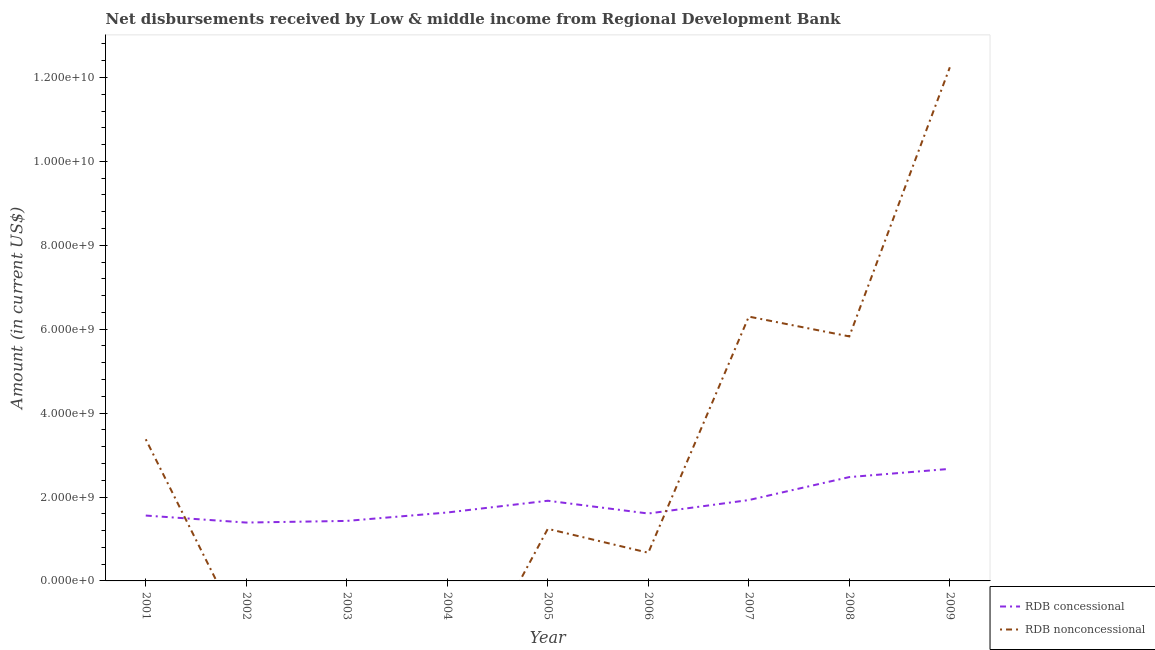How many different coloured lines are there?
Offer a very short reply. 2. Does the line corresponding to net non concessional disbursements from rdb intersect with the line corresponding to net concessional disbursements from rdb?
Make the answer very short. Yes. What is the net non concessional disbursements from rdb in 2001?
Offer a terse response. 3.38e+09. Across all years, what is the maximum net concessional disbursements from rdb?
Make the answer very short. 2.67e+09. Across all years, what is the minimum net concessional disbursements from rdb?
Offer a terse response. 1.39e+09. In which year was the net non concessional disbursements from rdb maximum?
Provide a succinct answer. 2009. What is the total net concessional disbursements from rdb in the graph?
Your answer should be very brief. 1.66e+1. What is the difference between the net concessional disbursements from rdb in 2005 and that in 2008?
Provide a succinct answer. -5.64e+08. What is the difference between the net concessional disbursements from rdb in 2005 and the net non concessional disbursements from rdb in 2003?
Give a very brief answer. 1.91e+09. What is the average net concessional disbursements from rdb per year?
Keep it short and to the point. 1.84e+09. In the year 2008, what is the difference between the net concessional disbursements from rdb and net non concessional disbursements from rdb?
Your answer should be compact. -3.35e+09. What is the ratio of the net concessional disbursements from rdb in 2003 to that in 2009?
Offer a terse response. 0.54. Is the net non concessional disbursements from rdb in 2007 less than that in 2009?
Keep it short and to the point. Yes. Is the difference between the net concessional disbursements from rdb in 2001 and 2007 greater than the difference between the net non concessional disbursements from rdb in 2001 and 2007?
Provide a succinct answer. Yes. What is the difference between the highest and the second highest net concessional disbursements from rdb?
Give a very brief answer. 1.96e+08. What is the difference between the highest and the lowest net concessional disbursements from rdb?
Make the answer very short. 1.28e+09. Is the sum of the net concessional disbursements from rdb in 2005 and 2008 greater than the maximum net non concessional disbursements from rdb across all years?
Provide a succinct answer. No. Does the net concessional disbursements from rdb monotonically increase over the years?
Your answer should be very brief. No. How many years are there in the graph?
Offer a terse response. 9. Are the values on the major ticks of Y-axis written in scientific E-notation?
Your response must be concise. Yes. Does the graph contain any zero values?
Keep it short and to the point. Yes. Does the graph contain grids?
Keep it short and to the point. No. How many legend labels are there?
Provide a short and direct response. 2. What is the title of the graph?
Your response must be concise. Net disbursements received by Low & middle income from Regional Development Bank. What is the label or title of the X-axis?
Your response must be concise. Year. What is the label or title of the Y-axis?
Keep it short and to the point. Amount (in current US$). What is the Amount (in current US$) in RDB concessional in 2001?
Ensure brevity in your answer.  1.56e+09. What is the Amount (in current US$) in RDB nonconcessional in 2001?
Your response must be concise. 3.38e+09. What is the Amount (in current US$) of RDB concessional in 2002?
Provide a short and direct response. 1.39e+09. What is the Amount (in current US$) of RDB nonconcessional in 2002?
Your answer should be compact. 0. What is the Amount (in current US$) in RDB concessional in 2003?
Give a very brief answer. 1.43e+09. What is the Amount (in current US$) of RDB nonconcessional in 2003?
Offer a very short reply. 0. What is the Amount (in current US$) of RDB concessional in 2004?
Your answer should be very brief. 1.63e+09. What is the Amount (in current US$) in RDB concessional in 2005?
Your response must be concise. 1.91e+09. What is the Amount (in current US$) of RDB nonconcessional in 2005?
Offer a terse response. 1.24e+09. What is the Amount (in current US$) of RDB concessional in 2006?
Make the answer very short. 1.61e+09. What is the Amount (in current US$) of RDB nonconcessional in 2006?
Your answer should be compact. 6.72e+08. What is the Amount (in current US$) of RDB concessional in 2007?
Provide a short and direct response. 1.93e+09. What is the Amount (in current US$) of RDB nonconcessional in 2007?
Keep it short and to the point. 6.30e+09. What is the Amount (in current US$) of RDB concessional in 2008?
Your response must be concise. 2.48e+09. What is the Amount (in current US$) in RDB nonconcessional in 2008?
Provide a short and direct response. 5.83e+09. What is the Amount (in current US$) of RDB concessional in 2009?
Offer a very short reply. 2.67e+09. What is the Amount (in current US$) in RDB nonconcessional in 2009?
Make the answer very short. 1.22e+1. Across all years, what is the maximum Amount (in current US$) in RDB concessional?
Give a very brief answer. 2.67e+09. Across all years, what is the maximum Amount (in current US$) in RDB nonconcessional?
Your answer should be very brief. 1.22e+1. Across all years, what is the minimum Amount (in current US$) in RDB concessional?
Provide a short and direct response. 1.39e+09. What is the total Amount (in current US$) in RDB concessional in the graph?
Ensure brevity in your answer.  1.66e+1. What is the total Amount (in current US$) of RDB nonconcessional in the graph?
Your answer should be very brief. 2.97e+1. What is the difference between the Amount (in current US$) in RDB concessional in 2001 and that in 2002?
Offer a terse response. 1.67e+08. What is the difference between the Amount (in current US$) in RDB concessional in 2001 and that in 2003?
Your answer should be very brief. 1.28e+08. What is the difference between the Amount (in current US$) of RDB concessional in 2001 and that in 2004?
Give a very brief answer. -7.27e+07. What is the difference between the Amount (in current US$) of RDB concessional in 2001 and that in 2005?
Make the answer very short. -3.53e+08. What is the difference between the Amount (in current US$) in RDB nonconcessional in 2001 and that in 2005?
Provide a succinct answer. 2.13e+09. What is the difference between the Amount (in current US$) in RDB concessional in 2001 and that in 2006?
Give a very brief answer. -4.85e+07. What is the difference between the Amount (in current US$) in RDB nonconcessional in 2001 and that in 2006?
Provide a short and direct response. 2.70e+09. What is the difference between the Amount (in current US$) in RDB concessional in 2001 and that in 2007?
Give a very brief answer. -3.69e+08. What is the difference between the Amount (in current US$) in RDB nonconcessional in 2001 and that in 2007?
Your answer should be very brief. -2.92e+09. What is the difference between the Amount (in current US$) in RDB concessional in 2001 and that in 2008?
Offer a terse response. -9.17e+08. What is the difference between the Amount (in current US$) in RDB nonconcessional in 2001 and that in 2008?
Make the answer very short. -2.45e+09. What is the difference between the Amount (in current US$) in RDB concessional in 2001 and that in 2009?
Provide a succinct answer. -1.11e+09. What is the difference between the Amount (in current US$) of RDB nonconcessional in 2001 and that in 2009?
Ensure brevity in your answer.  -8.87e+09. What is the difference between the Amount (in current US$) in RDB concessional in 2002 and that in 2003?
Keep it short and to the point. -3.94e+07. What is the difference between the Amount (in current US$) in RDB concessional in 2002 and that in 2004?
Your answer should be very brief. -2.40e+08. What is the difference between the Amount (in current US$) of RDB concessional in 2002 and that in 2005?
Provide a succinct answer. -5.20e+08. What is the difference between the Amount (in current US$) in RDB concessional in 2002 and that in 2006?
Offer a very short reply. -2.16e+08. What is the difference between the Amount (in current US$) of RDB concessional in 2002 and that in 2007?
Offer a terse response. -5.36e+08. What is the difference between the Amount (in current US$) in RDB concessional in 2002 and that in 2008?
Your response must be concise. -1.08e+09. What is the difference between the Amount (in current US$) of RDB concessional in 2002 and that in 2009?
Keep it short and to the point. -1.28e+09. What is the difference between the Amount (in current US$) in RDB concessional in 2003 and that in 2004?
Keep it short and to the point. -2.00e+08. What is the difference between the Amount (in current US$) of RDB concessional in 2003 and that in 2005?
Provide a short and direct response. -4.81e+08. What is the difference between the Amount (in current US$) in RDB concessional in 2003 and that in 2006?
Your answer should be compact. -1.76e+08. What is the difference between the Amount (in current US$) of RDB concessional in 2003 and that in 2007?
Your answer should be very brief. -4.97e+08. What is the difference between the Amount (in current US$) of RDB concessional in 2003 and that in 2008?
Provide a short and direct response. -1.04e+09. What is the difference between the Amount (in current US$) of RDB concessional in 2003 and that in 2009?
Your response must be concise. -1.24e+09. What is the difference between the Amount (in current US$) of RDB concessional in 2004 and that in 2005?
Offer a terse response. -2.80e+08. What is the difference between the Amount (in current US$) in RDB concessional in 2004 and that in 2006?
Provide a short and direct response. 2.43e+07. What is the difference between the Amount (in current US$) of RDB concessional in 2004 and that in 2007?
Give a very brief answer. -2.97e+08. What is the difference between the Amount (in current US$) in RDB concessional in 2004 and that in 2008?
Ensure brevity in your answer.  -8.44e+08. What is the difference between the Amount (in current US$) in RDB concessional in 2004 and that in 2009?
Make the answer very short. -1.04e+09. What is the difference between the Amount (in current US$) in RDB concessional in 2005 and that in 2006?
Your answer should be very brief. 3.04e+08. What is the difference between the Amount (in current US$) of RDB nonconcessional in 2005 and that in 2006?
Provide a short and direct response. 5.70e+08. What is the difference between the Amount (in current US$) in RDB concessional in 2005 and that in 2007?
Make the answer very short. -1.63e+07. What is the difference between the Amount (in current US$) in RDB nonconcessional in 2005 and that in 2007?
Offer a terse response. -5.06e+09. What is the difference between the Amount (in current US$) of RDB concessional in 2005 and that in 2008?
Your answer should be compact. -5.64e+08. What is the difference between the Amount (in current US$) in RDB nonconcessional in 2005 and that in 2008?
Provide a succinct answer. -4.59e+09. What is the difference between the Amount (in current US$) of RDB concessional in 2005 and that in 2009?
Offer a very short reply. -7.60e+08. What is the difference between the Amount (in current US$) in RDB nonconcessional in 2005 and that in 2009?
Your answer should be compact. -1.10e+1. What is the difference between the Amount (in current US$) in RDB concessional in 2006 and that in 2007?
Provide a short and direct response. -3.21e+08. What is the difference between the Amount (in current US$) of RDB nonconcessional in 2006 and that in 2007?
Provide a succinct answer. -5.63e+09. What is the difference between the Amount (in current US$) in RDB concessional in 2006 and that in 2008?
Offer a very short reply. -8.69e+08. What is the difference between the Amount (in current US$) of RDB nonconcessional in 2006 and that in 2008?
Your answer should be compact. -5.16e+09. What is the difference between the Amount (in current US$) of RDB concessional in 2006 and that in 2009?
Give a very brief answer. -1.06e+09. What is the difference between the Amount (in current US$) in RDB nonconcessional in 2006 and that in 2009?
Your answer should be compact. -1.16e+1. What is the difference between the Amount (in current US$) of RDB concessional in 2007 and that in 2008?
Provide a succinct answer. -5.48e+08. What is the difference between the Amount (in current US$) of RDB nonconcessional in 2007 and that in 2008?
Ensure brevity in your answer.  4.72e+08. What is the difference between the Amount (in current US$) in RDB concessional in 2007 and that in 2009?
Offer a terse response. -7.43e+08. What is the difference between the Amount (in current US$) of RDB nonconcessional in 2007 and that in 2009?
Offer a terse response. -5.94e+09. What is the difference between the Amount (in current US$) of RDB concessional in 2008 and that in 2009?
Offer a terse response. -1.96e+08. What is the difference between the Amount (in current US$) of RDB nonconcessional in 2008 and that in 2009?
Your answer should be very brief. -6.41e+09. What is the difference between the Amount (in current US$) of RDB concessional in 2001 and the Amount (in current US$) of RDB nonconcessional in 2005?
Ensure brevity in your answer.  3.17e+08. What is the difference between the Amount (in current US$) in RDB concessional in 2001 and the Amount (in current US$) in RDB nonconcessional in 2006?
Your response must be concise. 8.86e+08. What is the difference between the Amount (in current US$) of RDB concessional in 2001 and the Amount (in current US$) of RDB nonconcessional in 2007?
Your answer should be very brief. -4.74e+09. What is the difference between the Amount (in current US$) in RDB concessional in 2001 and the Amount (in current US$) in RDB nonconcessional in 2008?
Your response must be concise. -4.27e+09. What is the difference between the Amount (in current US$) of RDB concessional in 2001 and the Amount (in current US$) of RDB nonconcessional in 2009?
Provide a short and direct response. -1.07e+1. What is the difference between the Amount (in current US$) of RDB concessional in 2002 and the Amount (in current US$) of RDB nonconcessional in 2005?
Make the answer very short. 1.50e+08. What is the difference between the Amount (in current US$) of RDB concessional in 2002 and the Amount (in current US$) of RDB nonconcessional in 2006?
Your answer should be compact. 7.19e+08. What is the difference between the Amount (in current US$) in RDB concessional in 2002 and the Amount (in current US$) in RDB nonconcessional in 2007?
Offer a very short reply. -4.91e+09. What is the difference between the Amount (in current US$) in RDB concessional in 2002 and the Amount (in current US$) in RDB nonconcessional in 2008?
Your response must be concise. -4.44e+09. What is the difference between the Amount (in current US$) in RDB concessional in 2002 and the Amount (in current US$) in RDB nonconcessional in 2009?
Your answer should be very brief. -1.09e+1. What is the difference between the Amount (in current US$) of RDB concessional in 2003 and the Amount (in current US$) of RDB nonconcessional in 2005?
Provide a short and direct response. 1.89e+08. What is the difference between the Amount (in current US$) in RDB concessional in 2003 and the Amount (in current US$) in RDB nonconcessional in 2006?
Give a very brief answer. 7.59e+08. What is the difference between the Amount (in current US$) in RDB concessional in 2003 and the Amount (in current US$) in RDB nonconcessional in 2007?
Your answer should be compact. -4.87e+09. What is the difference between the Amount (in current US$) in RDB concessional in 2003 and the Amount (in current US$) in RDB nonconcessional in 2008?
Provide a succinct answer. -4.40e+09. What is the difference between the Amount (in current US$) in RDB concessional in 2003 and the Amount (in current US$) in RDB nonconcessional in 2009?
Your answer should be very brief. -1.08e+1. What is the difference between the Amount (in current US$) of RDB concessional in 2004 and the Amount (in current US$) of RDB nonconcessional in 2005?
Give a very brief answer. 3.89e+08. What is the difference between the Amount (in current US$) of RDB concessional in 2004 and the Amount (in current US$) of RDB nonconcessional in 2006?
Offer a terse response. 9.59e+08. What is the difference between the Amount (in current US$) in RDB concessional in 2004 and the Amount (in current US$) in RDB nonconcessional in 2007?
Offer a very short reply. -4.67e+09. What is the difference between the Amount (in current US$) in RDB concessional in 2004 and the Amount (in current US$) in RDB nonconcessional in 2008?
Make the answer very short. -4.20e+09. What is the difference between the Amount (in current US$) in RDB concessional in 2004 and the Amount (in current US$) in RDB nonconcessional in 2009?
Keep it short and to the point. -1.06e+1. What is the difference between the Amount (in current US$) in RDB concessional in 2005 and the Amount (in current US$) in RDB nonconcessional in 2006?
Your answer should be compact. 1.24e+09. What is the difference between the Amount (in current US$) in RDB concessional in 2005 and the Amount (in current US$) in RDB nonconcessional in 2007?
Provide a succinct answer. -4.39e+09. What is the difference between the Amount (in current US$) of RDB concessional in 2005 and the Amount (in current US$) of RDB nonconcessional in 2008?
Provide a short and direct response. -3.92e+09. What is the difference between the Amount (in current US$) in RDB concessional in 2005 and the Amount (in current US$) in RDB nonconcessional in 2009?
Give a very brief answer. -1.03e+1. What is the difference between the Amount (in current US$) of RDB concessional in 2006 and the Amount (in current US$) of RDB nonconcessional in 2007?
Provide a succinct answer. -4.69e+09. What is the difference between the Amount (in current US$) of RDB concessional in 2006 and the Amount (in current US$) of RDB nonconcessional in 2008?
Offer a very short reply. -4.22e+09. What is the difference between the Amount (in current US$) in RDB concessional in 2006 and the Amount (in current US$) in RDB nonconcessional in 2009?
Provide a short and direct response. -1.06e+1. What is the difference between the Amount (in current US$) of RDB concessional in 2007 and the Amount (in current US$) of RDB nonconcessional in 2008?
Your answer should be compact. -3.90e+09. What is the difference between the Amount (in current US$) in RDB concessional in 2007 and the Amount (in current US$) in RDB nonconcessional in 2009?
Offer a terse response. -1.03e+1. What is the difference between the Amount (in current US$) in RDB concessional in 2008 and the Amount (in current US$) in RDB nonconcessional in 2009?
Offer a very short reply. -9.77e+09. What is the average Amount (in current US$) of RDB concessional per year?
Your answer should be compact. 1.84e+09. What is the average Amount (in current US$) in RDB nonconcessional per year?
Ensure brevity in your answer.  3.30e+09. In the year 2001, what is the difference between the Amount (in current US$) of RDB concessional and Amount (in current US$) of RDB nonconcessional?
Ensure brevity in your answer.  -1.82e+09. In the year 2005, what is the difference between the Amount (in current US$) in RDB concessional and Amount (in current US$) in RDB nonconcessional?
Give a very brief answer. 6.70e+08. In the year 2006, what is the difference between the Amount (in current US$) of RDB concessional and Amount (in current US$) of RDB nonconcessional?
Provide a short and direct response. 9.35e+08. In the year 2007, what is the difference between the Amount (in current US$) in RDB concessional and Amount (in current US$) in RDB nonconcessional?
Keep it short and to the point. -4.37e+09. In the year 2008, what is the difference between the Amount (in current US$) of RDB concessional and Amount (in current US$) of RDB nonconcessional?
Your response must be concise. -3.35e+09. In the year 2009, what is the difference between the Amount (in current US$) in RDB concessional and Amount (in current US$) in RDB nonconcessional?
Keep it short and to the point. -9.57e+09. What is the ratio of the Amount (in current US$) of RDB concessional in 2001 to that in 2002?
Make the answer very short. 1.12. What is the ratio of the Amount (in current US$) in RDB concessional in 2001 to that in 2003?
Provide a succinct answer. 1.09. What is the ratio of the Amount (in current US$) of RDB concessional in 2001 to that in 2004?
Provide a succinct answer. 0.96. What is the ratio of the Amount (in current US$) of RDB concessional in 2001 to that in 2005?
Give a very brief answer. 0.82. What is the ratio of the Amount (in current US$) in RDB nonconcessional in 2001 to that in 2005?
Give a very brief answer. 2.72. What is the ratio of the Amount (in current US$) in RDB concessional in 2001 to that in 2006?
Provide a succinct answer. 0.97. What is the ratio of the Amount (in current US$) in RDB nonconcessional in 2001 to that in 2006?
Ensure brevity in your answer.  5.03. What is the ratio of the Amount (in current US$) of RDB concessional in 2001 to that in 2007?
Make the answer very short. 0.81. What is the ratio of the Amount (in current US$) in RDB nonconcessional in 2001 to that in 2007?
Ensure brevity in your answer.  0.54. What is the ratio of the Amount (in current US$) of RDB concessional in 2001 to that in 2008?
Give a very brief answer. 0.63. What is the ratio of the Amount (in current US$) of RDB nonconcessional in 2001 to that in 2008?
Ensure brevity in your answer.  0.58. What is the ratio of the Amount (in current US$) in RDB concessional in 2001 to that in 2009?
Your answer should be compact. 0.58. What is the ratio of the Amount (in current US$) in RDB nonconcessional in 2001 to that in 2009?
Provide a succinct answer. 0.28. What is the ratio of the Amount (in current US$) in RDB concessional in 2002 to that in 2003?
Give a very brief answer. 0.97. What is the ratio of the Amount (in current US$) of RDB concessional in 2002 to that in 2004?
Offer a terse response. 0.85. What is the ratio of the Amount (in current US$) in RDB concessional in 2002 to that in 2005?
Provide a succinct answer. 0.73. What is the ratio of the Amount (in current US$) in RDB concessional in 2002 to that in 2006?
Offer a terse response. 0.87. What is the ratio of the Amount (in current US$) in RDB concessional in 2002 to that in 2007?
Give a very brief answer. 0.72. What is the ratio of the Amount (in current US$) in RDB concessional in 2002 to that in 2008?
Your response must be concise. 0.56. What is the ratio of the Amount (in current US$) in RDB concessional in 2002 to that in 2009?
Keep it short and to the point. 0.52. What is the ratio of the Amount (in current US$) of RDB concessional in 2003 to that in 2004?
Give a very brief answer. 0.88. What is the ratio of the Amount (in current US$) of RDB concessional in 2003 to that in 2005?
Your answer should be compact. 0.75. What is the ratio of the Amount (in current US$) of RDB concessional in 2003 to that in 2006?
Your answer should be compact. 0.89. What is the ratio of the Amount (in current US$) of RDB concessional in 2003 to that in 2007?
Your response must be concise. 0.74. What is the ratio of the Amount (in current US$) of RDB concessional in 2003 to that in 2008?
Keep it short and to the point. 0.58. What is the ratio of the Amount (in current US$) of RDB concessional in 2003 to that in 2009?
Give a very brief answer. 0.54. What is the ratio of the Amount (in current US$) of RDB concessional in 2004 to that in 2005?
Give a very brief answer. 0.85. What is the ratio of the Amount (in current US$) in RDB concessional in 2004 to that in 2006?
Provide a short and direct response. 1.02. What is the ratio of the Amount (in current US$) in RDB concessional in 2004 to that in 2007?
Make the answer very short. 0.85. What is the ratio of the Amount (in current US$) in RDB concessional in 2004 to that in 2008?
Offer a terse response. 0.66. What is the ratio of the Amount (in current US$) in RDB concessional in 2004 to that in 2009?
Your answer should be compact. 0.61. What is the ratio of the Amount (in current US$) of RDB concessional in 2005 to that in 2006?
Your answer should be very brief. 1.19. What is the ratio of the Amount (in current US$) in RDB nonconcessional in 2005 to that in 2006?
Offer a terse response. 1.85. What is the ratio of the Amount (in current US$) of RDB concessional in 2005 to that in 2007?
Keep it short and to the point. 0.99. What is the ratio of the Amount (in current US$) in RDB nonconcessional in 2005 to that in 2007?
Provide a short and direct response. 0.2. What is the ratio of the Amount (in current US$) of RDB concessional in 2005 to that in 2008?
Make the answer very short. 0.77. What is the ratio of the Amount (in current US$) of RDB nonconcessional in 2005 to that in 2008?
Provide a short and direct response. 0.21. What is the ratio of the Amount (in current US$) of RDB concessional in 2005 to that in 2009?
Keep it short and to the point. 0.72. What is the ratio of the Amount (in current US$) of RDB nonconcessional in 2005 to that in 2009?
Offer a very short reply. 0.1. What is the ratio of the Amount (in current US$) in RDB concessional in 2006 to that in 2007?
Ensure brevity in your answer.  0.83. What is the ratio of the Amount (in current US$) in RDB nonconcessional in 2006 to that in 2007?
Provide a short and direct response. 0.11. What is the ratio of the Amount (in current US$) of RDB concessional in 2006 to that in 2008?
Offer a terse response. 0.65. What is the ratio of the Amount (in current US$) of RDB nonconcessional in 2006 to that in 2008?
Your answer should be compact. 0.12. What is the ratio of the Amount (in current US$) of RDB concessional in 2006 to that in 2009?
Keep it short and to the point. 0.6. What is the ratio of the Amount (in current US$) of RDB nonconcessional in 2006 to that in 2009?
Offer a terse response. 0.05. What is the ratio of the Amount (in current US$) of RDB concessional in 2007 to that in 2008?
Provide a short and direct response. 0.78. What is the ratio of the Amount (in current US$) of RDB nonconcessional in 2007 to that in 2008?
Provide a succinct answer. 1.08. What is the ratio of the Amount (in current US$) in RDB concessional in 2007 to that in 2009?
Your answer should be compact. 0.72. What is the ratio of the Amount (in current US$) in RDB nonconcessional in 2007 to that in 2009?
Your response must be concise. 0.51. What is the ratio of the Amount (in current US$) of RDB concessional in 2008 to that in 2009?
Provide a short and direct response. 0.93. What is the ratio of the Amount (in current US$) in RDB nonconcessional in 2008 to that in 2009?
Give a very brief answer. 0.48. What is the difference between the highest and the second highest Amount (in current US$) in RDB concessional?
Make the answer very short. 1.96e+08. What is the difference between the highest and the second highest Amount (in current US$) in RDB nonconcessional?
Give a very brief answer. 5.94e+09. What is the difference between the highest and the lowest Amount (in current US$) of RDB concessional?
Your response must be concise. 1.28e+09. What is the difference between the highest and the lowest Amount (in current US$) of RDB nonconcessional?
Give a very brief answer. 1.22e+1. 